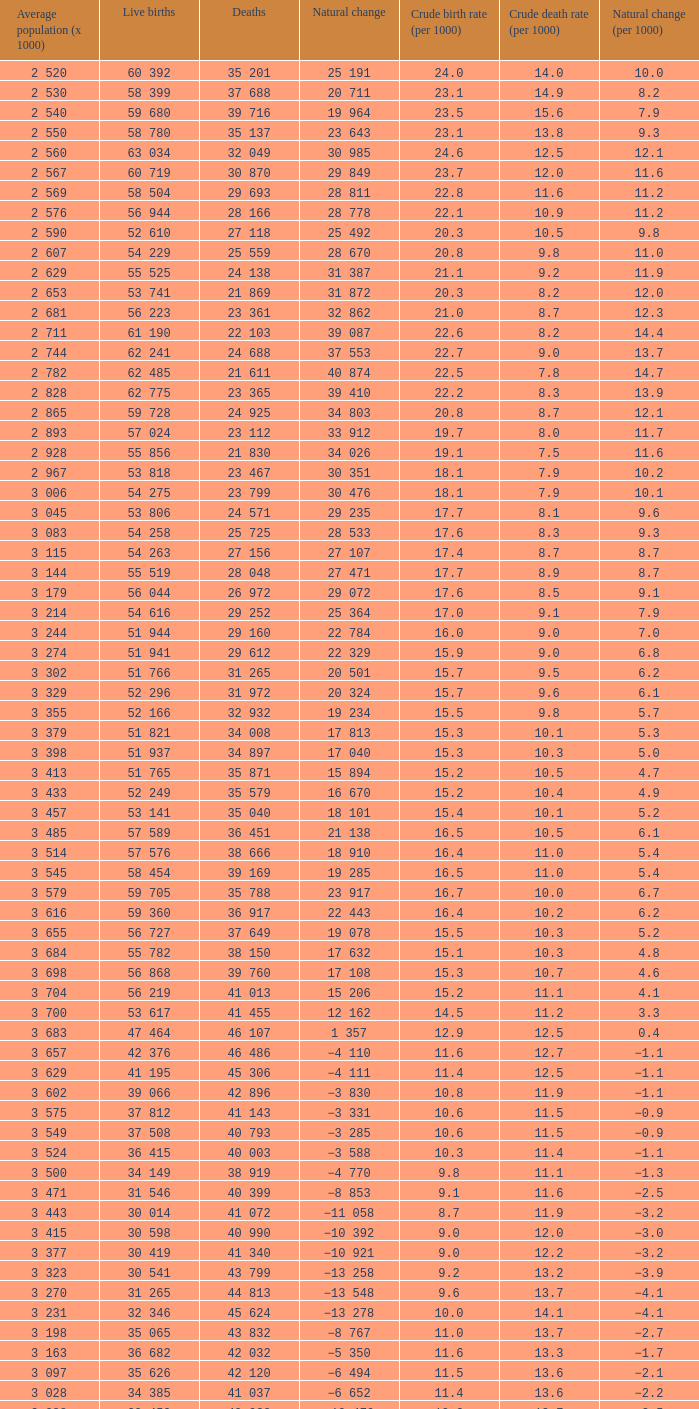Which Average population (x 1000) has a Crude death rate (per 1000) smaller than 10.9, and a Crude birth rate (per 1000) smaller than 19.7, and a Natural change (per 1000) of 8.7, and Live births of 54 263? 3 115. 